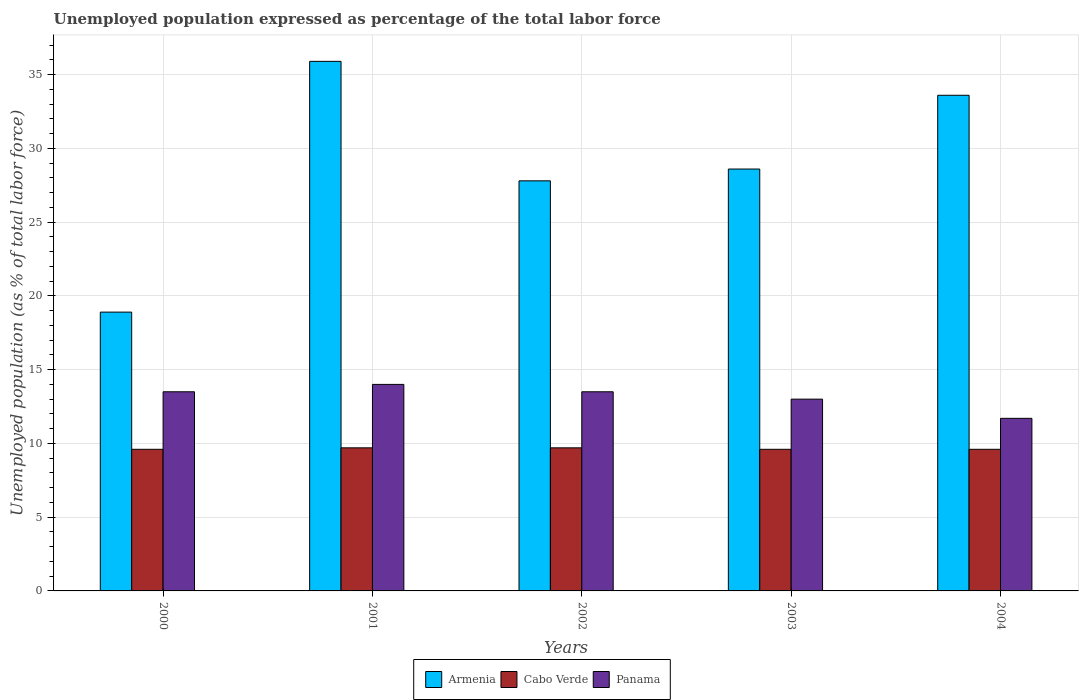How many groups of bars are there?
Offer a very short reply. 5. How many bars are there on the 5th tick from the left?
Ensure brevity in your answer.  3. How many bars are there on the 2nd tick from the right?
Your answer should be compact. 3. In how many cases, is the number of bars for a given year not equal to the number of legend labels?
Your answer should be compact. 0. What is the unemployment in in Armenia in 2002?
Your answer should be compact. 27.8. Across all years, what is the minimum unemployment in in Panama?
Ensure brevity in your answer.  11.7. In which year was the unemployment in in Cabo Verde minimum?
Your response must be concise. 2000. What is the total unemployment in in Cabo Verde in the graph?
Your answer should be compact. 48.2. What is the difference between the unemployment in in Panama in 2003 and that in 2004?
Offer a very short reply. 1.3. What is the difference between the unemployment in in Cabo Verde in 2002 and the unemployment in in Panama in 2004?
Your answer should be very brief. -2. What is the average unemployment in in Armenia per year?
Your answer should be compact. 28.96. In the year 2000, what is the difference between the unemployment in in Cabo Verde and unemployment in in Panama?
Offer a terse response. -3.9. In how many years, is the unemployment in in Armenia greater than 29 %?
Your response must be concise. 2. What is the ratio of the unemployment in in Panama in 2001 to that in 2004?
Your answer should be compact. 1.2. Is the difference between the unemployment in in Cabo Verde in 2000 and 2004 greater than the difference between the unemployment in in Panama in 2000 and 2004?
Your answer should be very brief. No. What is the difference between the highest and the second highest unemployment in in Armenia?
Provide a short and direct response. 2.3. What is the difference between the highest and the lowest unemployment in in Panama?
Provide a short and direct response. 2.3. In how many years, is the unemployment in in Armenia greater than the average unemployment in in Armenia taken over all years?
Ensure brevity in your answer.  2. Is the sum of the unemployment in in Cabo Verde in 2000 and 2001 greater than the maximum unemployment in in Armenia across all years?
Keep it short and to the point. No. What does the 1st bar from the left in 2002 represents?
Offer a very short reply. Armenia. What does the 1st bar from the right in 2002 represents?
Provide a succinct answer. Panama. Are the values on the major ticks of Y-axis written in scientific E-notation?
Give a very brief answer. No. Does the graph contain any zero values?
Provide a succinct answer. No. What is the title of the graph?
Give a very brief answer. Unemployed population expressed as percentage of the total labor force. What is the label or title of the X-axis?
Keep it short and to the point. Years. What is the label or title of the Y-axis?
Provide a succinct answer. Unemployed population (as % of total labor force). What is the Unemployed population (as % of total labor force) of Armenia in 2000?
Ensure brevity in your answer.  18.9. What is the Unemployed population (as % of total labor force) in Cabo Verde in 2000?
Provide a succinct answer. 9.6. What is the Unemployed population (as % of total labor force) of Panama in 2000?
Make the answer very short. 13.5. What is the Unemployed population (as % of total labor force) of Armenia in 2001?
Provide a succinct answer. 35.9. What is the Unemployed population (as % of total labor force) in Cabo Verde in 2001?
Make the answer very short. 9.7. What is the Unemployed population (as % of total labor force) of Panama in 2001?
Provide a short and direct response. 14. What is the Unemployed population (as % of total labor force) of Armenia in 2002?
Give a very brief answer. 27.8. What is the Unemployed population (as % of total labor force) in Cabo Verde in 2002?
Offer a very short reply. 9.7. What is the Unemployed population (as % of total labor force) in Panama in 2002?
Give a very brief answer. 13.5. What is the Unemployed population (as % of total labor force) of Armenia in 2003?
Ensure brevity in your answer.  28.6. What is the Unemployed population (as % of total labor force) in Cabo Verde in 2003?
Your answer should be very brief. 9.6. What is the Unemployed population (as % of total labor force) of Armenia in 2004?
Offer a very short reply. 33.6. What is the Unemployed population (as % of total labor force) of Cabo Verde in 2004?
Your response must be concise. 9.6. What is the Unemployed population (as % of total labor force) of Panama in 2004?
Your response must be concise. 11.7. Across all years, what is the maximum Unemployed population (as % of total labor force) in Armenia?
Provide a short and direct response. 35.9. Across all years, what is the maximum Unemployed population (as % of total labor force) in Cabo Verde?
Your answer should be very brief. 9.7. Across all years, what is the minimum Unemployed population (as % of total labor force) of Armenia?
Give a very brief answer. 18.9. Across all years, what is the minimum Unemployed population (as % of total labor force) in Cabo Verde?
Your response must be concise. 9.6. Across all years, what is the minimum Unemployed population (as % of total labor force) of Panama?
Make the answer very short. 11.7. What is the total Unemployed population (as % of total labor force) of Armenia in the graph?
Ensure brevity in your answer.  144.8. What is the total Unemployed population (as % of total labor force) in Cabo Verde in the graph?
Make the answer very short. 48.2. What is the total Unemployed population (as % of total labor force) of Panama in the graph?
Provide a succinct answer. 65.7. What is the difference between the Unemployed population (as % of total labor force) in Armenia in 2000 and that in 2001?
Ensure brevity in your answer.  -17. What is the difference between the Unemployed population (as % of total labor force) in Cabo Verde in 2000 and that in 2001?
Provide a succinct answer. -0.1. What is the difference between the Unemployed population (as % of total labor force) in Panama in 2000 and that in 2001?
Your response must be concise. -0.5. What is the difference between the Unemployed population (as % of total labor force) in Panama in 2000 and that in 2003?
Make the answer very short. 0.5. What is the difference between the Unemployed population (as % of total labor force) of Armenia in 2000 and that in 2004?
Provide a succinct answer. -14.7. What is the difference between the Unemployed population (as % of total labor force) of Cabo Verde in 2001 and that in 2002?
Keep it short and to the point. 0. What is the difference between the Unemployed population (as % of total labor force) in Panama in 2001 and that in 2002?
Keep it short and to the point. 0.5. What is the difference between the Unemployed population (as % of total labor force) in Armenia in 2001 and that in 2003?
Your answer should be very brief. 7.3. What is the difference between the Unemployed population (as % of total labor force) in Cabo Verde in 2001 and that in 2003?
Your response must be concise. 0.1. What is the difference between the Unemployed population (as % of total labor force) of Panama in 2001 and that in 2003?
Give a very brief answer. 1. What is the difference between the Unemployed population (as % of total labor force) in Armenia in 2002 and that in 2003?
Your answer should be compact. -0.8. What is the difference between the Unemployed population (as % of total labor force) of Cabo Verde in 2002 and that in 2003?
Make the answer very short. 0.1. What is the difference between the Unemployed population (as % of total labor force) of Armenia in 2002 and that in 2004?
Offer a terse response. -5.8. What is the difference between the Unemployed population (as % of total labor force) of Cabo Verde in 2002 and that in 2004?
Keep it short and to the point. 0.1. What is the difference between the Unemployed population (as % of total labor force) in Panama in 2002 and that in 2004?
Offer a terse response. 1.8. What is the difference between the Unemployed population (as % of total labor force) in Cabo Verde in 2003 and that in 2004?
Your answer should be very brief. 0. What is the difference between the Unemployed population (as % of total labor force) of Armenia in 2000 and the Unemployed population (as % of total labor force) of Cabo Verde in 2001?
Offer a terse response. 9.2. What is the difference between the Unemployed population (as % of total labor force) in Cabo Verde in 2000 and the Unemployed population (as % of total labor force) in Panama in 2001?
Keep it short and to the point. -4.4. What is the difference between the Unemployed population (as % of total labor force) in Armenia in 2000 and the Unemployed population (as % of total labor force) in Cabo Verde in 2002?
Provide a short and direct response. 9.2. What is the difference between the Unemployed population (as % of total labor force) of Armenia in 2000 and the Unemployed population (as % of total labor force) of Panama in 2002?
Ensure brevity in your answer.  5.4. What is the difference between the Unemployed population (as % of total labor force) of Cabo Verde in 2000 and the Unemployed population (as % of total labor force) of Panama in 2002?
Your response must be concise. -3.9. What is the difference between the Unemployed population (as % of total labor force) in Armenia in 2000 and the Unemployed population (as % of total labor force) in Cabo Verde in 2004?
Make the answer very short. 9.3. What is the difference between the Unemployed population (as % of total labor force) in Cabo Verde in 2000 and the Unemployed population (as % of total labor force) in Panama in 2004?
Your answer should be compact. -2.1. What is the difference between the Unemployed population (as % of total labor force) in Armenia in 2001 and the Unemployed population (as % of total labor force) in Cabo Verde in 2002?
Give a very brief answer. 26.2. What is the difference between the Unemployed population (as % of total labor force) in Armenia in 2001 and the Unemployed population (as % of total labor force) in Panama in 2002?
Provide a succinct answer. 22.4. What is the difference between the Unemployed population (as % of total labor force) of Cabo Verde in 2001 and the Unemployed population (as % of total labor force) of Panama in 2002?
Provide a succinct answer. -3.8. What is the difference between the Unemployed population (as % of total labor force) in Armenia in 2001 and the Unemployed population (as % of total labor force) in Cabo Verde in 2003?
Provide a short and direct response. 26.3. What is the difference between the Unemployed population (as % of total labor force) in Armenia in 2001 and the Unemployed population (as % of total labor force) in Panama in 2003?
Provide a short and direct response. 22.9. What is the difference between the Unemployed population (as % of total labor force) of Armenia in 2001 and the Unemployed population (as % of total labor force) of Cabo Verde in 2004?
Offer a very short reply. 26.3. What is the difference between the Unemployed population (as % of total labor force) in Armenia in 2001 and the Unemployed population (as % of total labor force) in Panama in 2004?
Keep it short and to the point. 24.2. What is the difference between the Unemployed population (as % of total labor force) of Cabo Verde in 2001 and the Unemployed population (as % of total labor force) of Panama in 2004?
Give a very brief answer. -2. What is the difference between the Unemployed population (as % of total labor force) in Armenia in 2002 and the Unemployed population (as % of total labor force) in Cabo Verde in 2004?
Your answer should be compact. 18.2. What is the average Unemployed population (as % of total labor force) in Armenia per year?
Keep it short and to the point. 28.96. What is the average Unemployed population (as % of total labor force) of Cabo Verde per year?
Your answer should be compact. 9.64. What is the average Unemployed population (as % of total labor force) in Panama per year?
Offer a very short reply. 13.14. In the year 2000, what is the difference between the Unemployed population (as % of total labor force) in Armenia and Unemployed population (as % of total labor force) in Cabo Verde?
Give a very brief answer. 9.3. In the year 2000, what is the difference between the Unemployed population (as % of total labor force) of Armenia and Unemployed population (as % of total labor force) of Panama?
Your answer should be very brief. 5.4. In the year 2000, what is the difference between the Unemployed population (as % of total labor force) of Cabo Verde and Unemployed population (as % of total labor force) of Panama?
Make the answer very short. -3.9. In the year 2001, what is the difference between the Unemployed population (as % of total labor force) in Armenia and Unemployed population (as % of total labor force) in Cabo Verde?
Give a very brief answer. 26.2. In the year 2001, what is the difference between the Unemployed population (as % of total labor force) of Armenia and Unemployed population (as % of total labor force) of Panama?
Your answer should be compact. 21.9. In the year 2002, what is the difference between the Unemployed population (as % of total labor force) in Armenia and Unemployed population (as % of total labor force) in Cabo Verde?
Keep it short and to the point. 18.1. In the year 2002, what is the difference between the Unemployed population (as % of total labor force) in Armenia and Unemployed population (as % of total labor force) in Panama?
Provide a short and direct response. 14.3. In the year 2004, what is the difference between the Unemployed population (as % of total labor force) in Armenia and Unemployed population (as % of total labor force) in Cabo Verde?
Offer a very short reply. 24. In the year 2004, what is the difference between the Unemployed population (as % of total labor force) in Armenia and Unemployed population (as % of total labor force) in Panama?
Your answer should be compact. 21.9. What is the ratio of the Unemployed population (as % of total labor force) in Armenia in 2000 to that in 2001?
Ensure brevity in your answer.  0.53. What is the ratio of the Unemployed population (as % of total labor force) of Armenia in 2000 to that in 2002?
Ensure brevity in your answer.  0.68. What is the ratio of the Unemployed population (as % of total labor force) in Cabo Verde in 2000 to that in 2002?
Offer a terse response. 0.99. What is the ratio of the Unemployed population (as % of total labor force) in Armenia in 2000 to that in 2003?
Your answer should be very brief. 0.66. What is the ratio of the Unemployed population (as % of total labor force) in Panama in 2000 to that in 2003?
Provide a succinct answer. 1.04. What is the ratio of the Unemployed population (as % of total labor force) of Armenia in 2000 to that in 2004?
Keep it short and to the point. 0.56. What is the ratio of the Unemployed population (as % of total labor force) in Cabo Verde in 2000 to that in 2004?
Give a very brief answer. 1. What is the ratio of the Unemployed population (as % of total labor force) of Panama in 2000 to that in 2004?
Offer a very short reply. 1.15. What is the ratio of the Unemployed population (as % of total labor force) in Armenia in 2001 to that in 2002?
Keep it short and to the point. 1.29. What is the ratio of the Unemployed population (as % of total labor force) in Cabo Verde in 2001 to that in 2002?
Offer a terse response. 1. What is the ratio of the Unemployed population (as % of total labor force) in Panama in 2001 to that in 2002?
Offer a terse response. 1.04. What is the ratio of the Unemployed population (as % of total labor force) in Armenia in 2001 to that in 2003?
Give a very brief answer. 1.26. What is the ratio of the Unemployed population (as % of total labor force) of Cabo Verde in 2001 to that in 2003?
Your response must be concise. 1.01. What is the ratio of the Unemployed population (as % of total labor force) in Armenia in 2001 to that in 2004?
Your response must be concise. 1.07. What is the ratio of the Unemployed population (as % of total labor force) of Cabo Verde in 2001 to that in 2004?
Your answer should be very brief. 1.01. What is the ratio of the Unemployed population (as % of total labor force) in Panama in 2001 to that in 2004?
Keep it short and to the point. 1.2. What is the ratio of the Unemployed population (as % of total labor force) in Armenia in 2002 to that in 2003?
Your response must be concise. 0.97. What is the ratio of the Unemployed population (as % of total labor force) in Cabo Verde in 2002 to that in 2003?
Your answer should be very brief. 1.01. What is the ratio of the Unemployed population (as % of total labor force) in Panama in 2002 to that in 2003?
Keep it short and to the point. 1.04. What is the ratio of the Unemployed population (as % of total labor force) in Armenia in 2002 to that in 2004?
Provide a short and direct response. 0.83. What is the ratio of the Unemployed population (as % of total labor force) in Cabo Verde in 2002 to that in 2004?
Your answer should be compact. 1.01. What is the ratio of the Unemployed population (as % of total labor force) in Panama in 2002 to that in 2004?
Offer a very short reply. 1.15. What is the ratio of the Unemployed population (as % of total labor force) in Armenia in 2003 to that in 2004?
Your answer should be very brief. 0.85. What is the ratio of the Unemployed population (as % of total labor force) of Cabo Verde in 2003 to that in 2004?
Keep it short and to the point. 1. What is the ratio of the Unemployed population (as % of total labor force) in Panama in 2003 to that in 2004?
Provide a succinct answer. 1.11. What is the difference between the highest and the second highest Unemployed population (as % of total labor force) of Armenia?
Your answer should be very brief. 2.3. What is the difference between the highest and the second highest Unemployed population (as % of total labor force) in Cabo Verde?
Provide a succinct answer. 0. What is the difference between the highest and the lowest Unemployed population (as % of total labor force) of Cabo Verde?
Your answer should be compact. 0.1. What is the difference between the highest and the lowest Unemployed population (as % of total labor force) of Panama?
Provide a short and direct response. 2.3. 